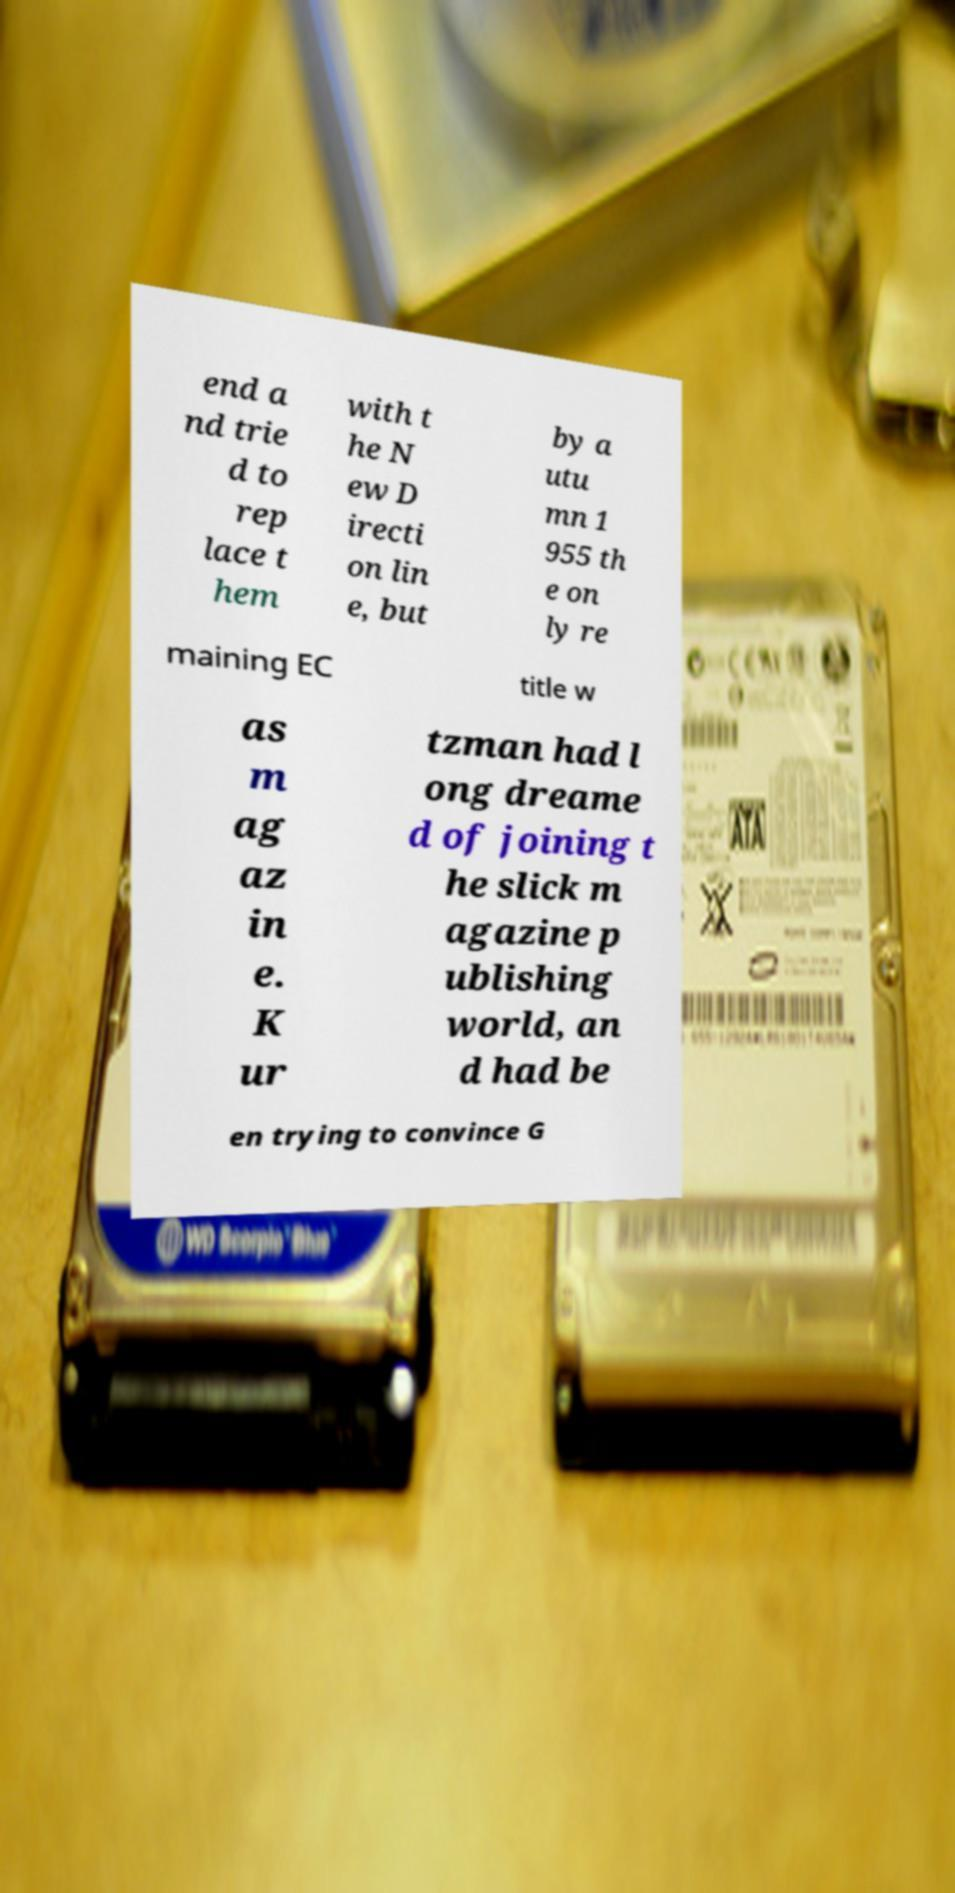What messages or text are displayed in this image? I need them in a readable, typed format. end a nd trie d to rep lace t hem with t he N ew D irecti on lin e, but by a utu mn 1 955 th e on ly re maining EC title w as m ag az in e. K ur tzman had l ong dreame d of joining t he slick m agazine p ublishing world, an d had be en trying to convince G 